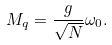Convert formula to latex. <formula><loc_0><loc_0><loc_500><loc_500>M _ { q } = \frac { g } { \sqrt { N } } \omega _ { 0 } .</formula> 